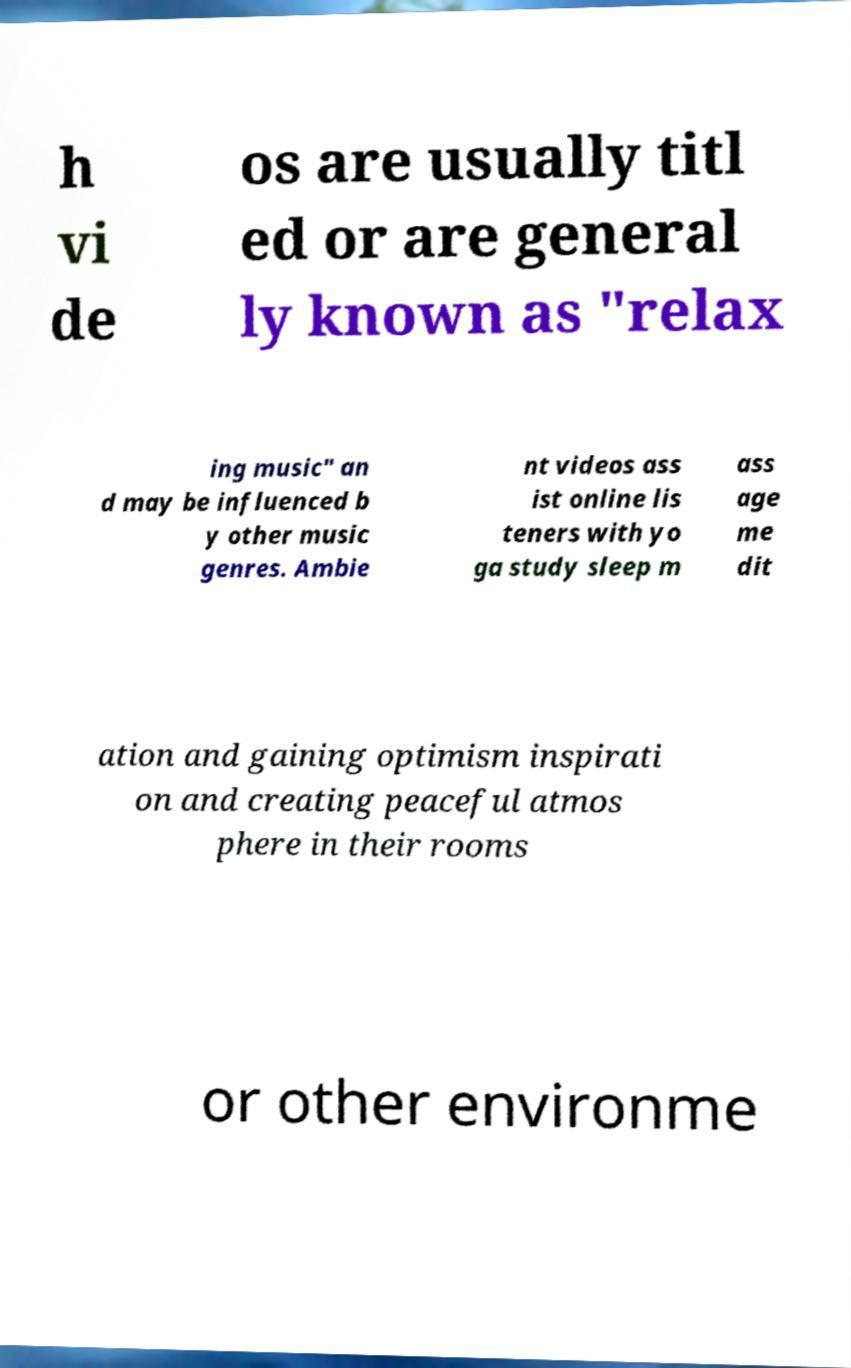Please read and relay the text visible in this image. What does it say? h vi de os are usually titl ed or are general ly known as "relax ing music" an d may be influenced b y other music genres. Ambie nt videos ass ist online lis teners with yo ga study sleep m ass age me dit ation and gaining optimism inspirati on and creating peaceful atmos phere in their rooms or other environme 